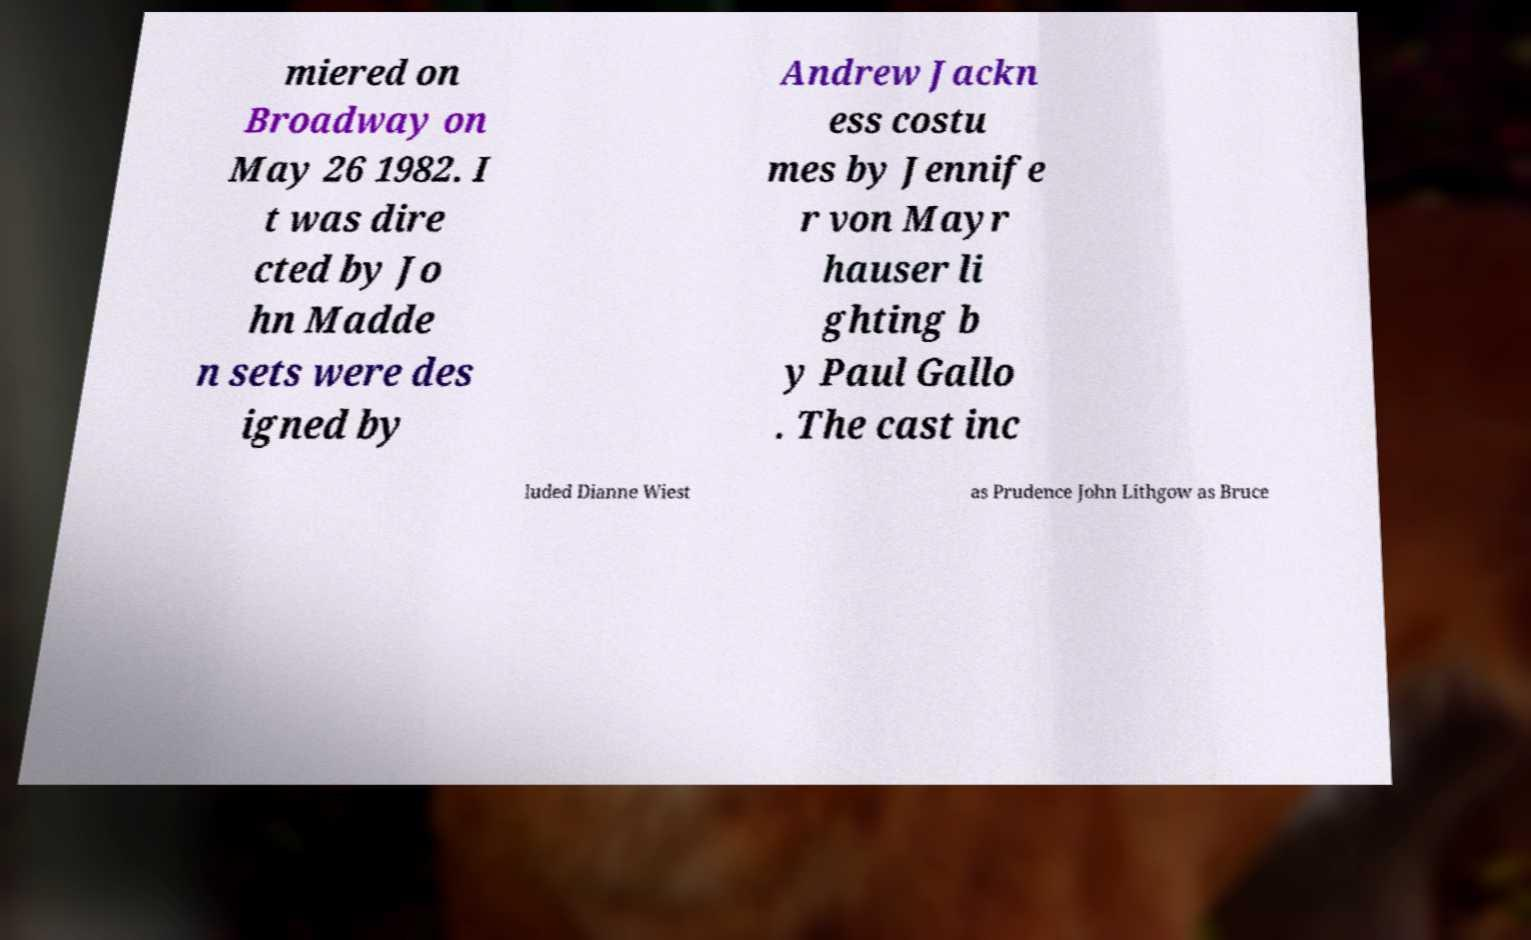What messages or text are displayed in this image? I need them in a readable, typed format. miered on Broadway on May 26 1982. I t was dire cted by Jo hn Madde n sets were des igned by Andrew Jackn ess costu mes by Jennife r von Mayr hauser li ghting b y Paul Gallo . The cast inc luded Dianne Wiest as Prudence John Lithgow as Bruce 